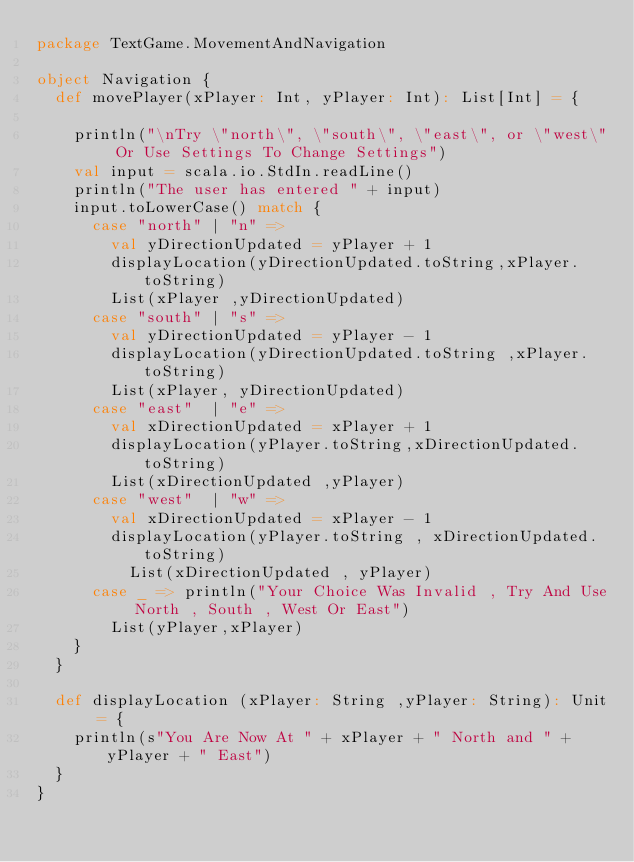Convert code to text. <code><loc_0><loc_0><loc_500><loc_500><_Scala_>package TextGame.MovementAndNavigation

object Navigation {
  def movePlayer(xPlayer: Int, yPlayer: Int): List[Int] = {

    println("\nTry \"north\", \"south\", \"east\", or \"west\" Or Use Settings To Change Settings")
    val input = scala.io.StdIn.readLine()
    println("The user has entered " + input)
    input.toLowerCase() match {
      case "north" | "n" =>
        val yDirectionUpdated = yPlayer + 1
        displayLocation(yDirectionUpdated.toString,xPlayer.toString)
        List(xPlayer ,yDirectionUpdated)
      case "south" | "s" =>
        val yDirectionUpdated = yPlayer - 1
        displayLocation(yDirectionUpdated.toString ,xPlayer.toString)
        List(xPlayer, yDirectionUpdated)
      case "east"  | "e" =>
        val xDirectionUpdated = xPlayer + 1
        displayLocation(yPlayer.toString,xDirectionUpdated.toString)
        List(xDirectionUpdated ,yPlayer)
      case "west"  | "w" =>
        val xDirectionUpdated = xPlayer - 1
        displayLocation(yPlayer.toString , xDirectionUpdated.toString)
          List(xDirectionUpdated , yPlayer)
      case _ => println("Your Choice Was Invalid , Try And Use North , South , West Or East")
        List(yPlayer,xPlayer)
    }
  }

  def displayLocation (xPlayer: String ,yPlayer: String): Unit = {
    println(s"You Are Now At " + xPlayer + " North and " + yPlayer + " East")
  }
}</code> 